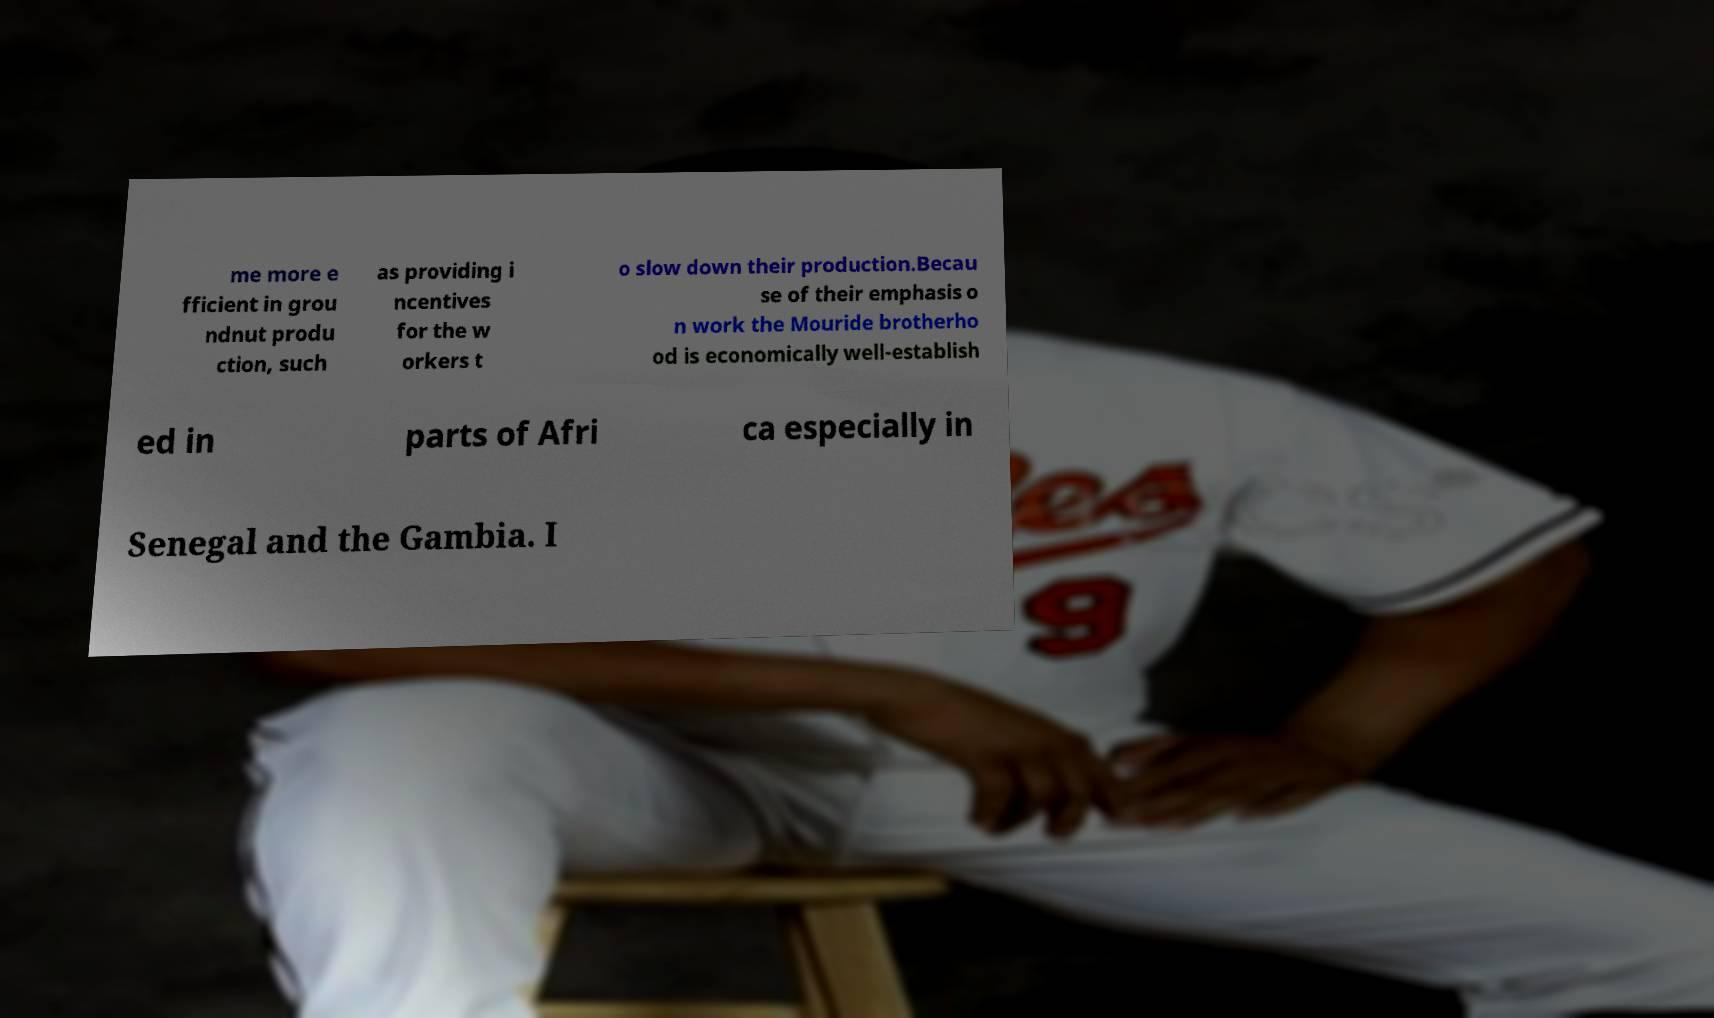Could you assist in decoding the text presented in this image and type it out clearly? me more e fficient in grou ndnut produ ction, such as providing i ncentives for the w orkers t o slow down their production.Becau se of their emphasis o n work the Mouride brotherho od is economically well-establish ed in parts of Afri ca especially in Senegal and the Gambia. I 